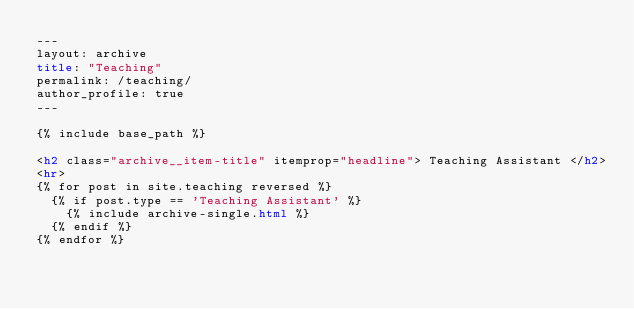<code> <loc_0><loc_0><loc_500><loc_500><_HTML_>---
layout: archive
title: "Teaching"
permalink: /teaching/
author_profile: true
---

{% include base_path %}

<h2 class="archive__item-title" itemprop="headline"> Teaching Assistant </h2>
<hr>
{% for post in site.teaching reversed %}
  {% if post.type == 'Teaching Assistant' %}
    {% include archive-single.html %}
  {% endif %}
{% endfor %}
</code> 